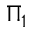<formula> <loc_0><loc_0><loc_500><loc_500>\Pi _ { 1 }</formula> 